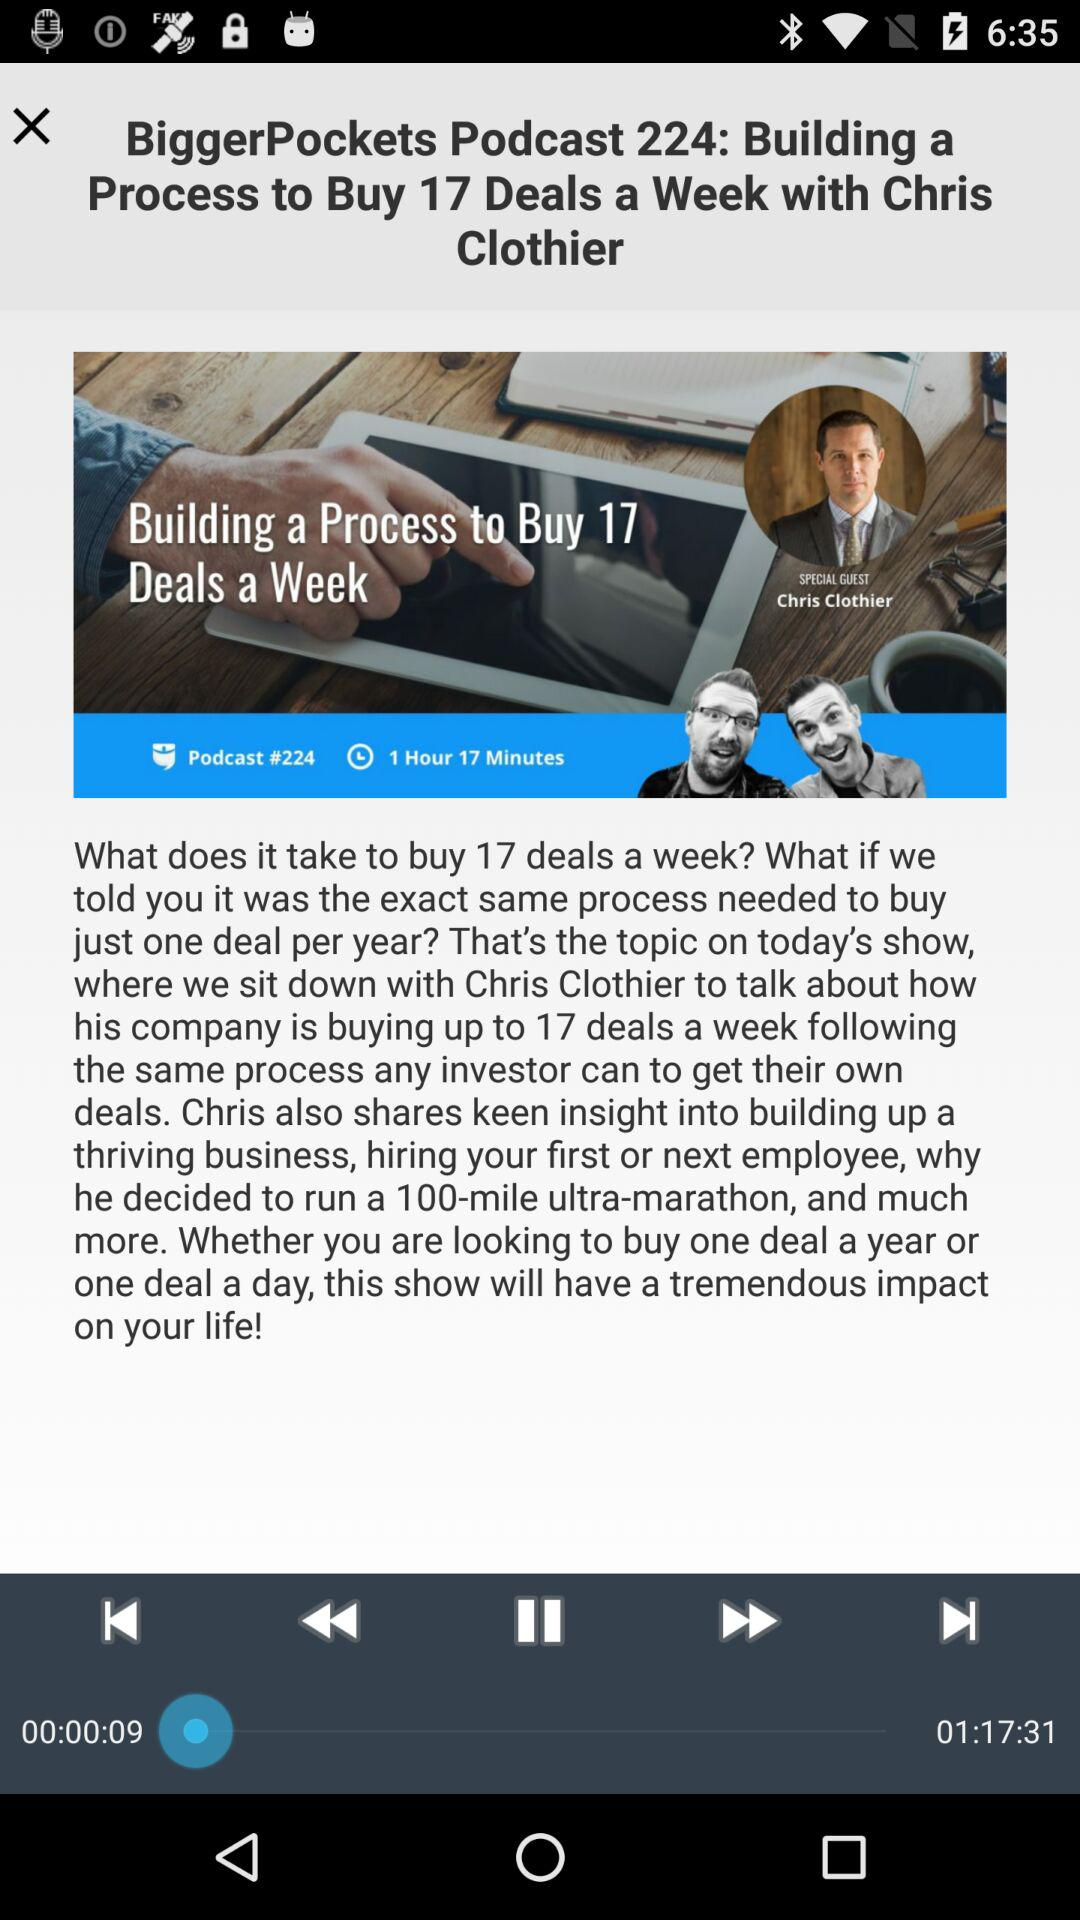What is the podcast number? The podcast number is 224. 